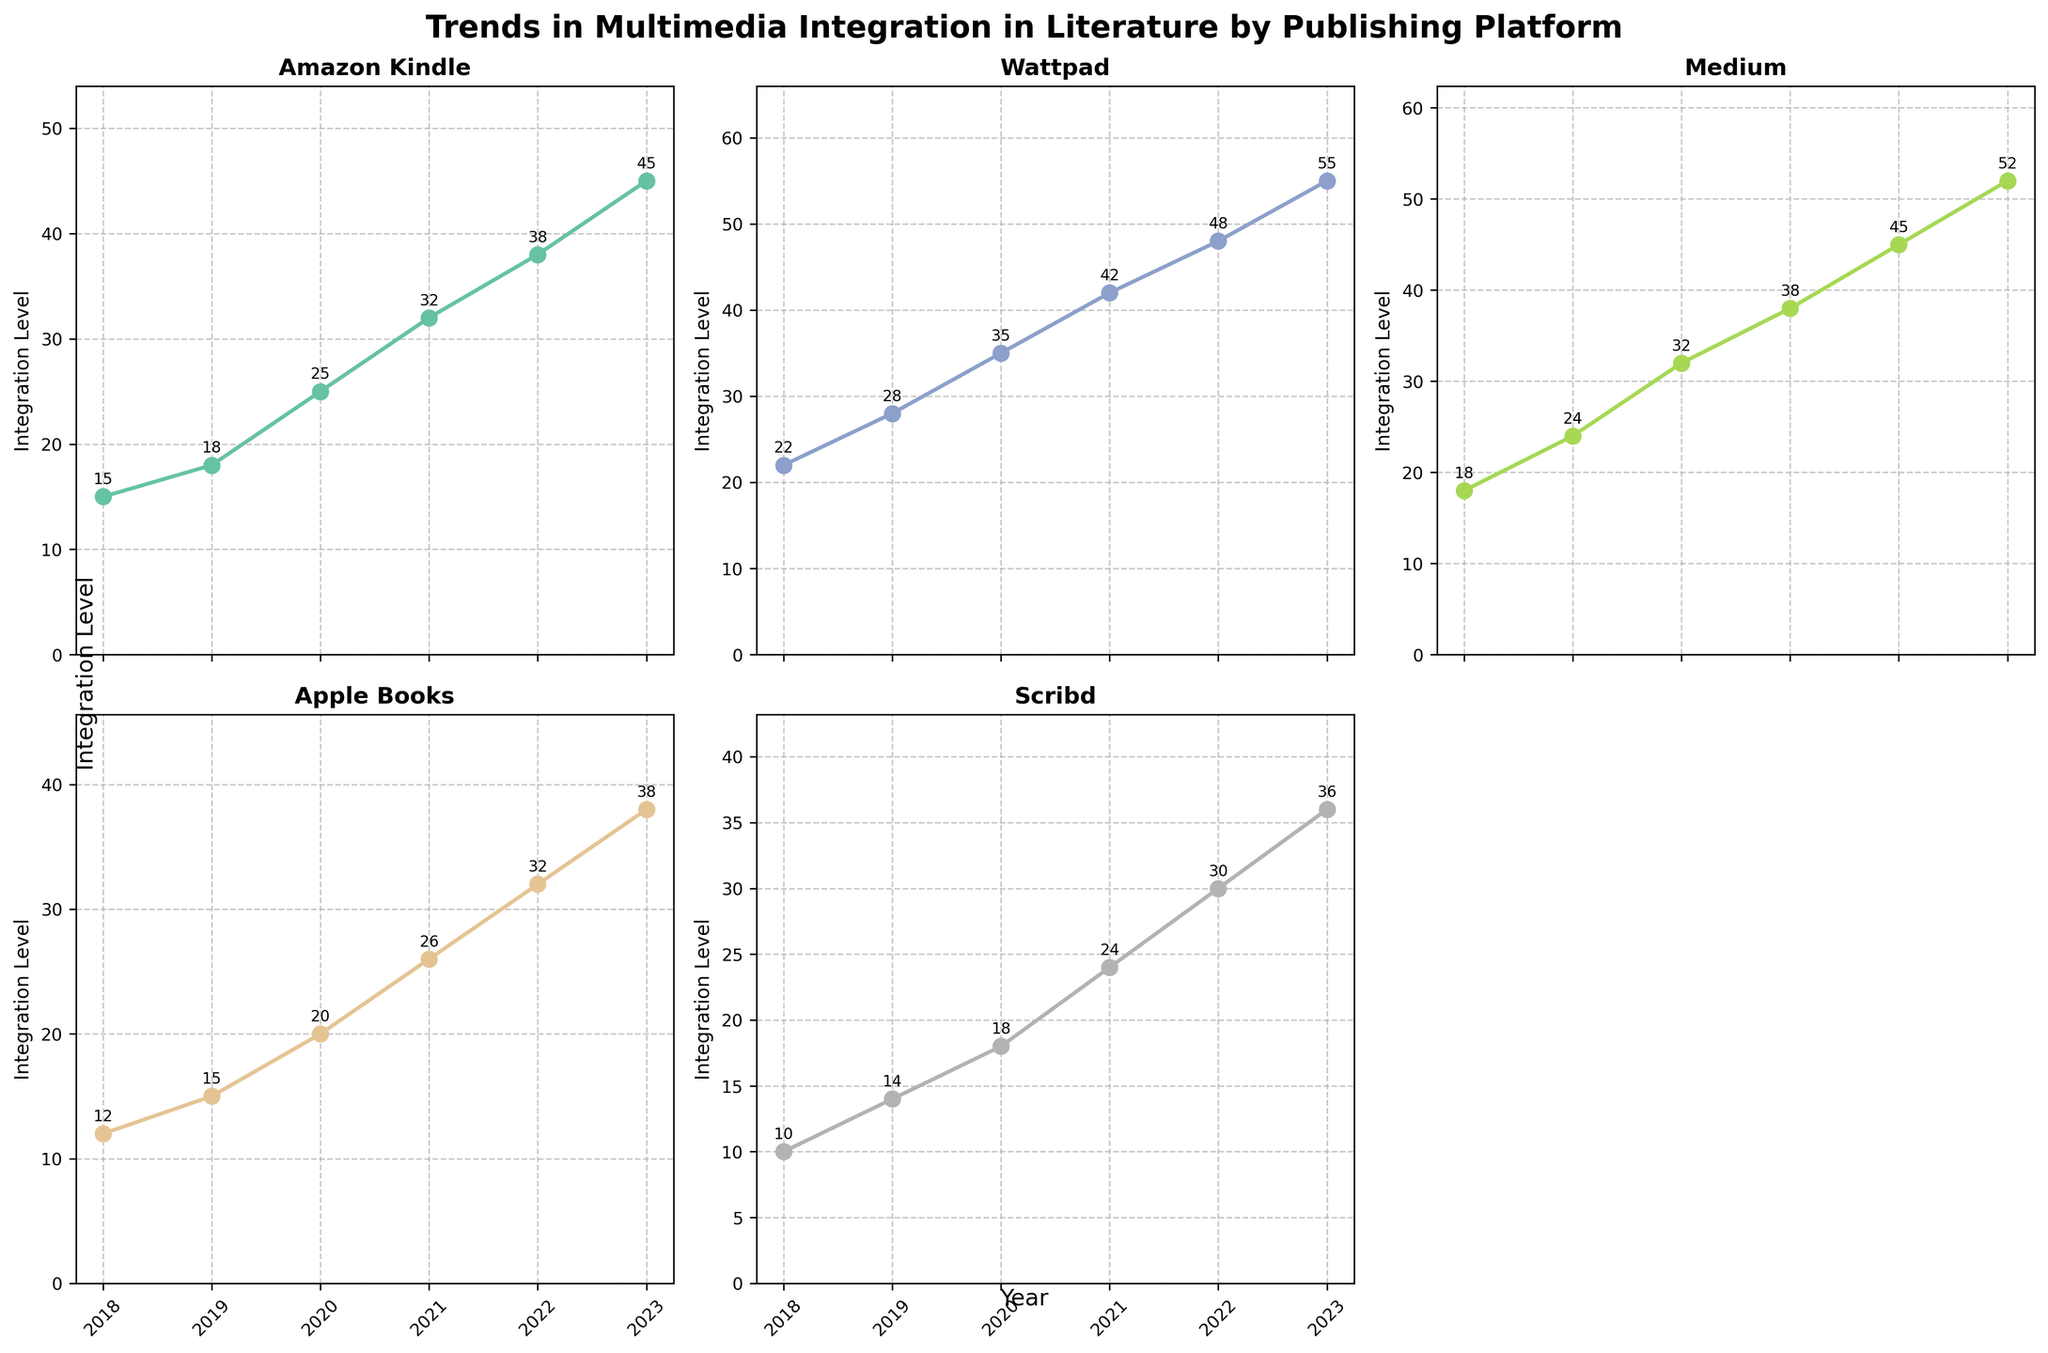What is the title of the figure? The title of the figure is displayed at the top, in bold and larger font compared to other text elements. The title reads "Trends in Multimedia Integration in Literature by Publishing Platform".
Answer: Trends in Multimedia Integration in Literature by Publishing Platform How many subplots are there in the figure? The figure is divided into a grid layout of subplots, specifically shown by the arrangement of axes and titles for different platforms. Counting them gives a total of 5 subplots.
Answer: 5 Which publishing platform shows the highest integration level in 2023? By looking at the data points marked for the year 2023 across all subplots, particularly those annotated with numeric values, the highest value appears for Wattpad at 55.
Answer: Wattpad Which platform showed the smallest increase in integration level from 2018 to 2023? Calculating the difference between the integration levels in 2023 and 2018 for each subplot: Amazon Kindle (45-15=30), Wattpad (55-22=33), Medium (52-18=34), Apple Books (38-12=26), and Scribd (36-10=26). Both Apple Books and Scribd have the smallest increase of 26.
Answer: Apple Books and Scribd What is the trend observed for Medium from 2018 to 2023? Observing the Medium subplot, the line trend indicates a continuous increase in the integration level over the years, increasing from 18 in 2018 to 52 in 2023.
Answer: Continuous increase Are there any platforms showing an equal integration level in any given year? Comparing the annotated values for each year across different subplots, there are no instances where two platforms have the exact same integration level in any single year.
Answer: No How does the integration level for Apple Books in 2022 compare to that in 2021? In 2022, Apple Books shows an integration level of 32, while in 2021 it is 26. The difference is calculated as 32 - 26, which shows an increase.
Answer: 6 increase Which platform had the most significant change in integration level between 2021 and 2022? By extracting the differences: Amazon Kindle (38-32=6), Wattpad (48-42=6), Medium (45-38=7), Apple Books (32-26=6), and Scribd (30-24=6). The most significant change is observed in Medium, with a difference of 7.
Answer: Medium What is the average integration level for Scribd from 2018 to 2023? Sum the integration levels for Scribd over the years from 2018 to 2023: 10+14+18+24+30+36 = 132. Divide this sum by the number of years (6): 132/6 = 22.
Answer: 22 